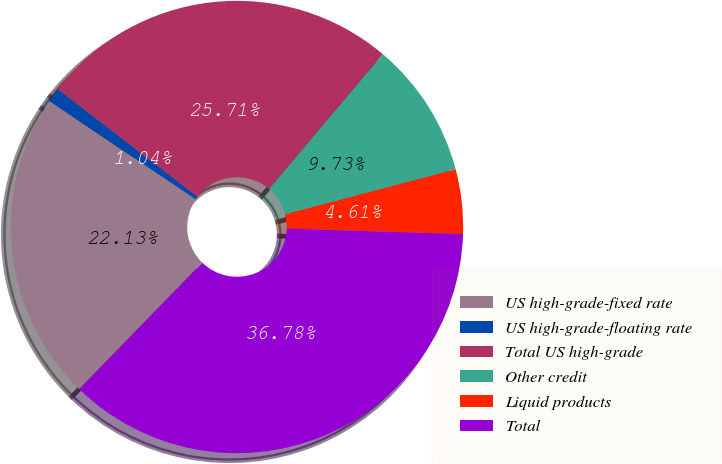<chart> <loc_0><loc_0><loc_500><loc_500><pie_chart><fcel>US high-grade-fixed rate<fcel>US high-grade-floating rate<fcel>Total US high-grade<fcel>Other credit<fcel>Liquid products<fcel>Total<nl><fcel>22.13%<fcel>1.04%<fcel>25.71%<fcel>9.73%<fcel>4.61%<fcel>36.78%<nl></chart> 